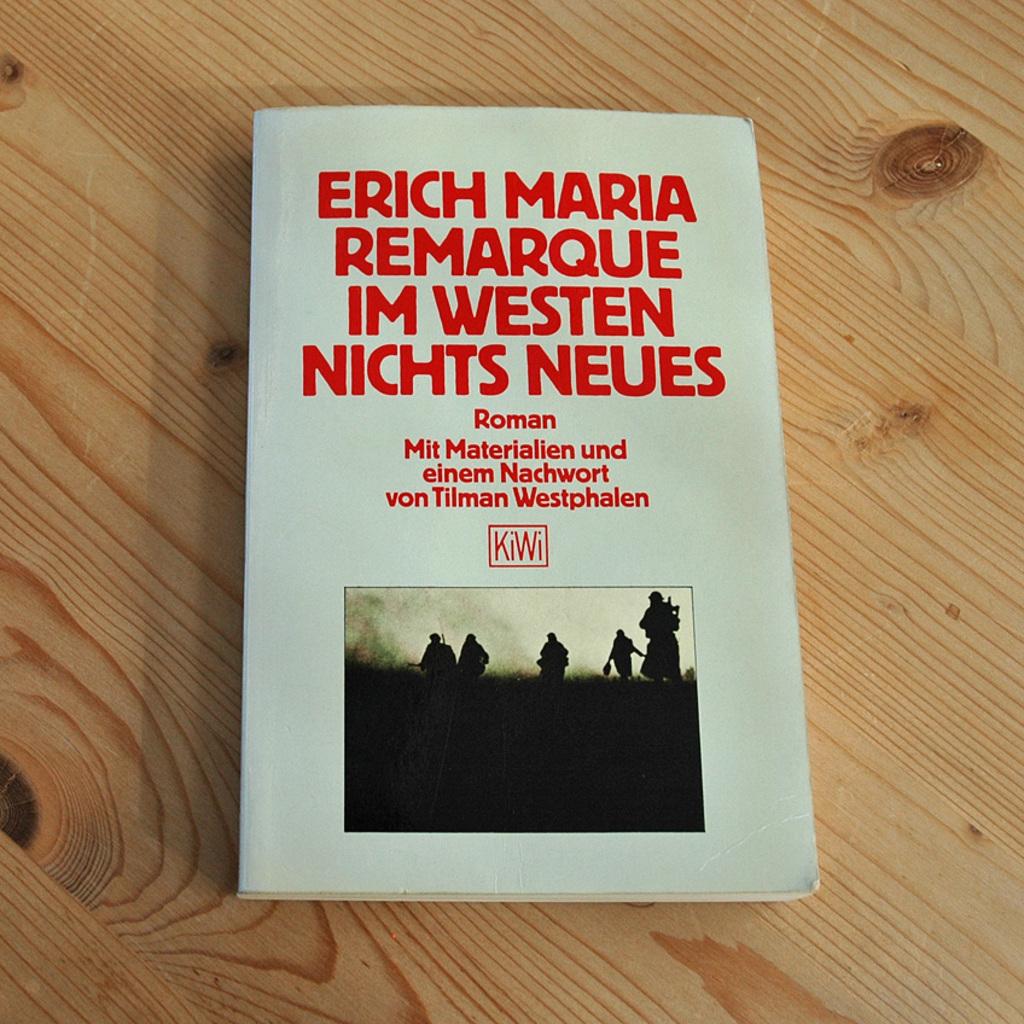What does it say in the red square?
Provide a short and direct response. Kiwi. 